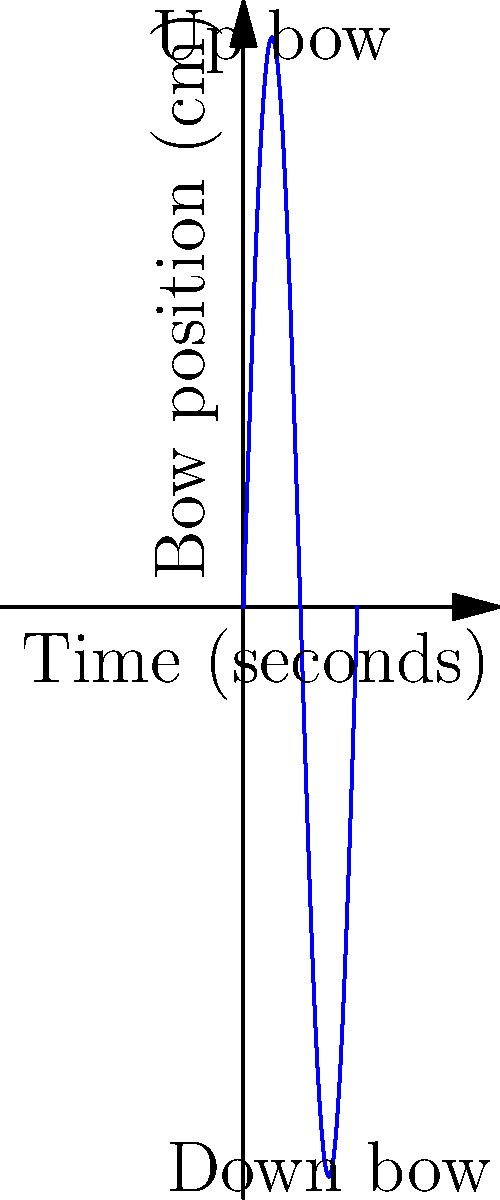A cellist's bow movement is represented on a coordinate plane, where the x-axis represents time in seconds and the y-axis represents bow position in centimeters from the frog (0 cm) to the tip (60 cm). The graph shows a sinusoidal pattern of bow movement over 4 seconds. What is the period of this bowing pattern, and what does it represent in terms of the cellist's technique? Let's analyze this graph step-by-step:

1. The graph shows a sinusoidal pattern, which represents the back-and-forth motion of the bow.

2. To find the period, we need to determine how long it takes for one complete cycle of the pattern to occur.

3. We can see that the pattern starts at the middle point (30 cm), goes up to the tip (60 cm), then down to the frog (0 cm), and back to the middle point.

4. This complete cycle occurs over 4 seconds, as shown on the x-axis.

5. Therefore, the period of this bowing pattern is 4 seconds.

6. In terms of the cellist's technique, this represents:
   - One complete down bow (from middle to tip to middle) taking 2 seconds
   - One complete up bow (from middle to frog to middle) taking 2 seconds

7. This regular, symmetrical pattern suggests a controlled, even bowing technique, likely for a piece with a moderate tempo and consistent rhythm.
Answer: 4 seconds; one complete down-and-up bow cycle 